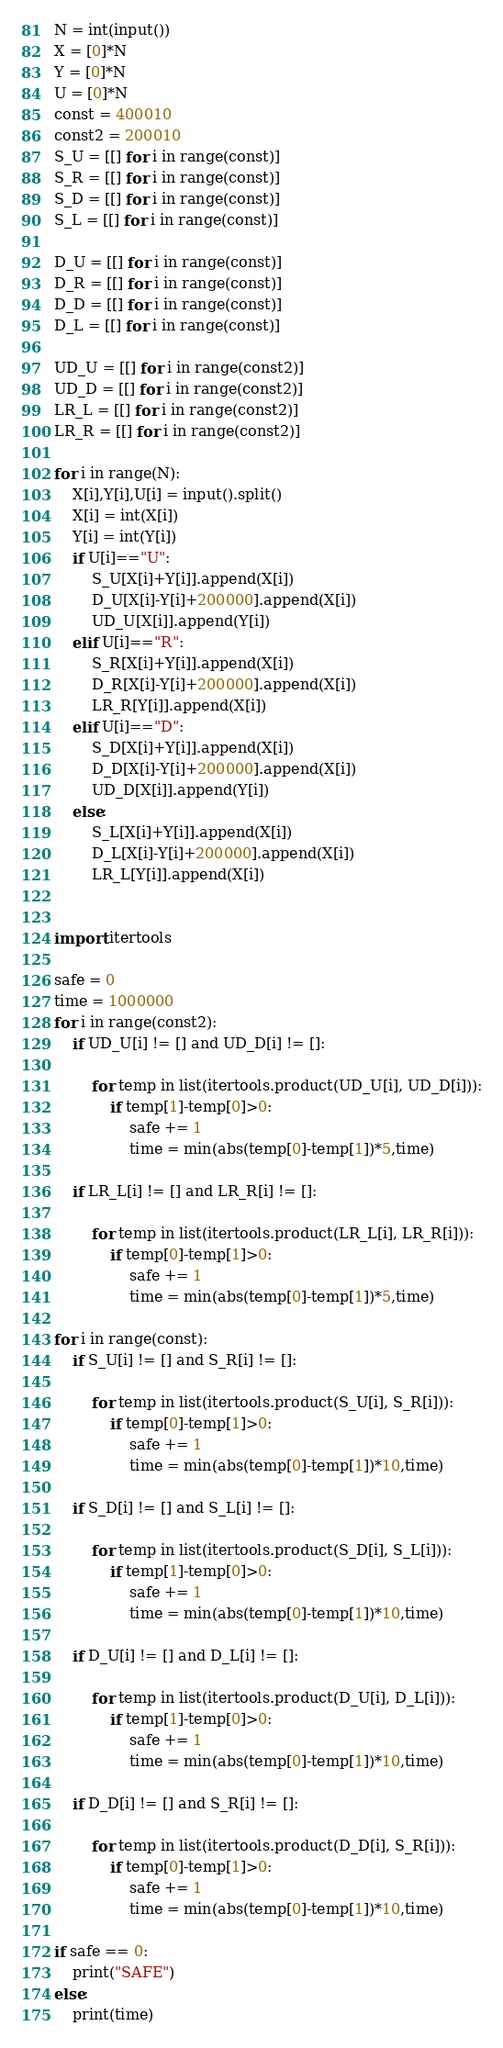<code> <loc_0><loc_0><loc_500><loc_500><_Python_>N = int(input())
X = [0]*N
Y = [0]*N
U = [0]*N
const = 400010
const2 = 200010
S_U = [[] for i in range(const)]
S_R = [[] for i in range(const)]
S_D = [[] for i in range(const)]
S_L = [[] for i in range(const)]

D_U = [[] for i in range(const)]
D_R = [[] for i in range(const)]
D_D = [[] for i in range(const)]
D_L = [[] for i in range(const)]

UD_U = [[] for i in range(const2)]
UD_D = [[] for i in range(const2)]
LR_L = [[] for i in range(const2)]
LR_R = [[] for i in range(const2)]

for i in range(N):
    X[i],Y[i],U[i] = input().split()
    X[i] = int(X[i])
    Y[i] = int(Y[i])
    if U[i]=="U":
        S_U[X[i]+Y[i]].append(X[i])
        D_U[X[i]-Y[i]+200000].append(X[i])
        UD_U[X[i]].append(Y[i])
    elif U[i]=="R":
        S_R[X[i]+Y[i]].append(X[i])
        D_R[X[i]-Y[i]+200000].append(X[i])
        LR_R[Y[i]].append(X[i])
    elif U[i]=="D":
        S_D[X[i]+Y[i]].append(X[i])
        D_D[X[i]-Y[i]+200000].append(X[i])
        UD_D[X[i]].append(Y[i])
    else:
        S_L[X[i]+Y[i]].append(X[i])
        D_L[X[i]-Y[i]+200000].append(X[i])
        LR_L[Y[i]].append(X[i])
        
        
import itertools

safe = 0
time = 1000000
for i in range(const2):
    if UD_U[i] != [] and UD_D[i] != []:

        for temp in list(itertools.product(UD_U[i], UD_D[i])):
            if temp[1]-temp[0]>0:
                safe += 1
                time = min(abs(temp[0]-temp[1])*5,time)

    if LR_L[i] != [] and LR_R[i] != []:

        for temp in list(itertools.product(LR_L[i], LR_R[i])):
            if temp[0]-temp[1]>0:
                safe += 1
                time = min(abs(temp[0]-temp[1])*5,time)

for i in range(const):
    if S_U[i] != [] and S_R[i] != []:

        for temp in list(itertools.product(S_U[i], S_R[i])):
            if temp[0]-temp[1]>0:
                safe += 1
                time = min(abs(temp[0]-temp[1])*10,time)
            
    if S_D[i] != [] and S_L[i] != []:

        for temp in list(itertools.product(S_D[i], S_L[i])):
            if temp[1]-temp[0]>0:
                safe += 1
                time = min(abs(temp[0]-temp[1])*10,time)
            
    if D_U[i] != [] and D_L[i] != []:

        for temp in list(itertools.product(D_U[i], D_L[i])):
            if temp[1]-temp[0]>0:
                safe += 1
                time = min(abs(temp[0]-temp[1])*10,time)
            
    if D_D[i] != [] and S_R[i] != []:

        for temp in list(itertools.product(D_D[i], S_R[i])):
            if temp[0]-temp[1]>0:
                safe += 1
                time = min(abs(temp[0]-temp[1])*10,time)

if safe == 0:
    print("SAFE")
else:
    print(time)</code> 